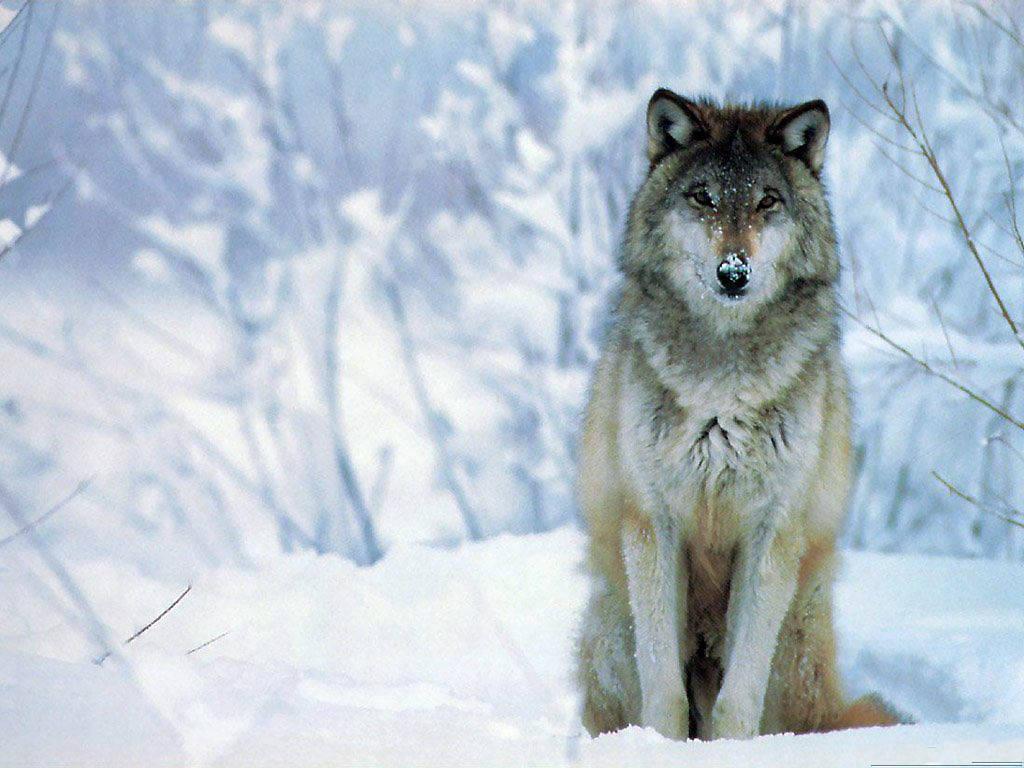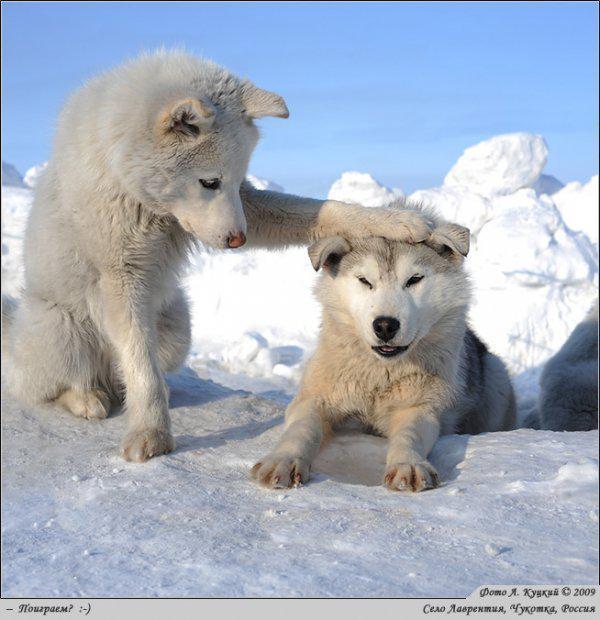The first image is the image on the left, the second image is the image on the right. Considering the images on both sides, is "You can see two or more wolves side by side in one of the pictures." valid? Answer yes or no. Yes. The first image is the image on the left, the second image is the image on the right. Given the left and right images, does the statement "The left image shows a camera-gazing wolf with a bit of snow on its fur, and the right image contains two wolves in the foreground." hold true? Answer yes or no. Yes. 